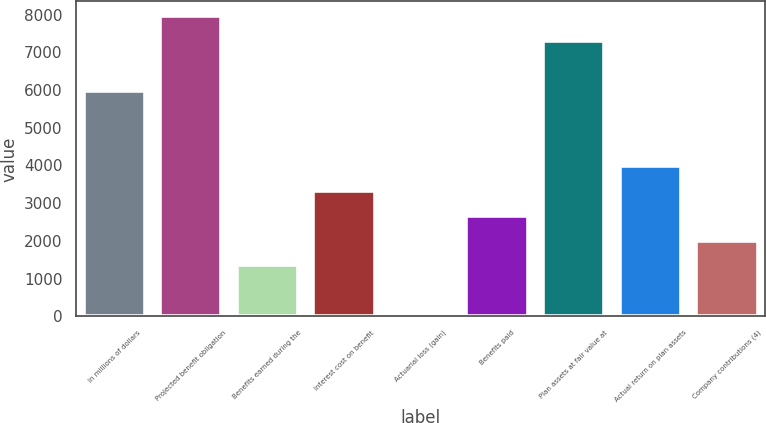Convert chart to OTSL. <chart><loc_0><loc_0><loc_500><loc_500><bar_chart><fcel>In millions of dollars<fcel>Projected benefit obligation<fcel>Benefits earned during the<fcel>Interest cost on benefit<fcel>Actuarial loss (gain)<fcel>Benefits paid<fcel>Plan assets at fair value at<fcel>Actual return on plan assets<fcel>Company contributions (4)<nl><fcel>5968.9<fcel>7949.2<fcel>1348.2<fcel>3328.5<fcel>28<fcel>2668.4<fcel>7289.1<fcel>3988.6<fcel>2008.3<nl></chart> 